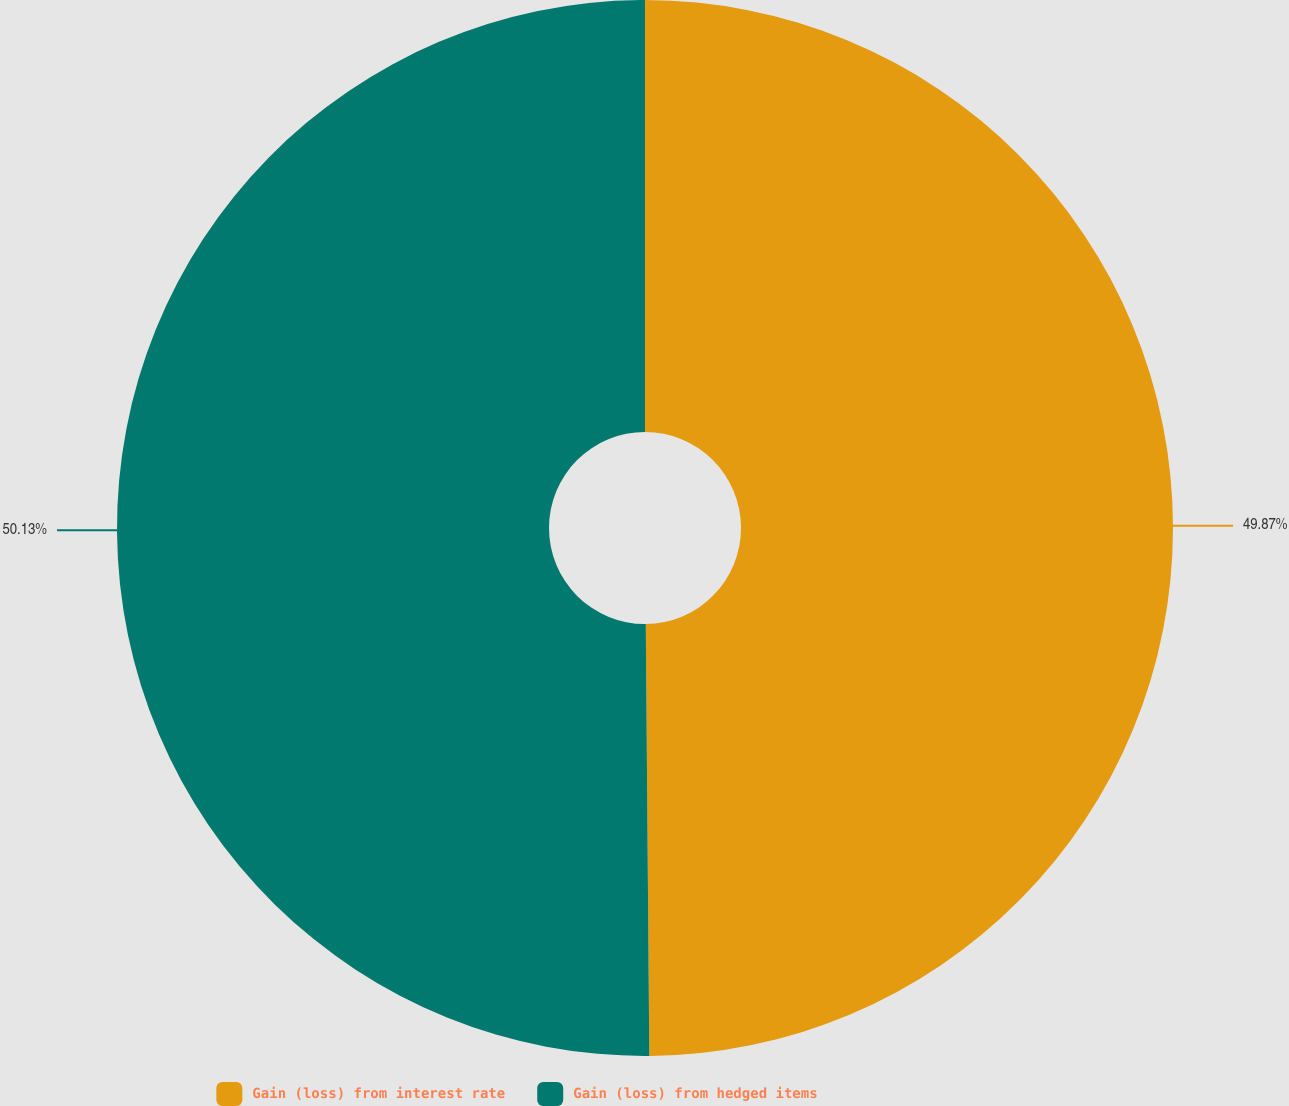Convert chart. <chart><loc_0><loc_0><loc_500><loc_500><pie_chart><fcel>Gain (loss) from interest rate<fcel>Gain (loss) from hedged items<nl><fcel>49.87%<fcel>50.13%<nl></chart> 